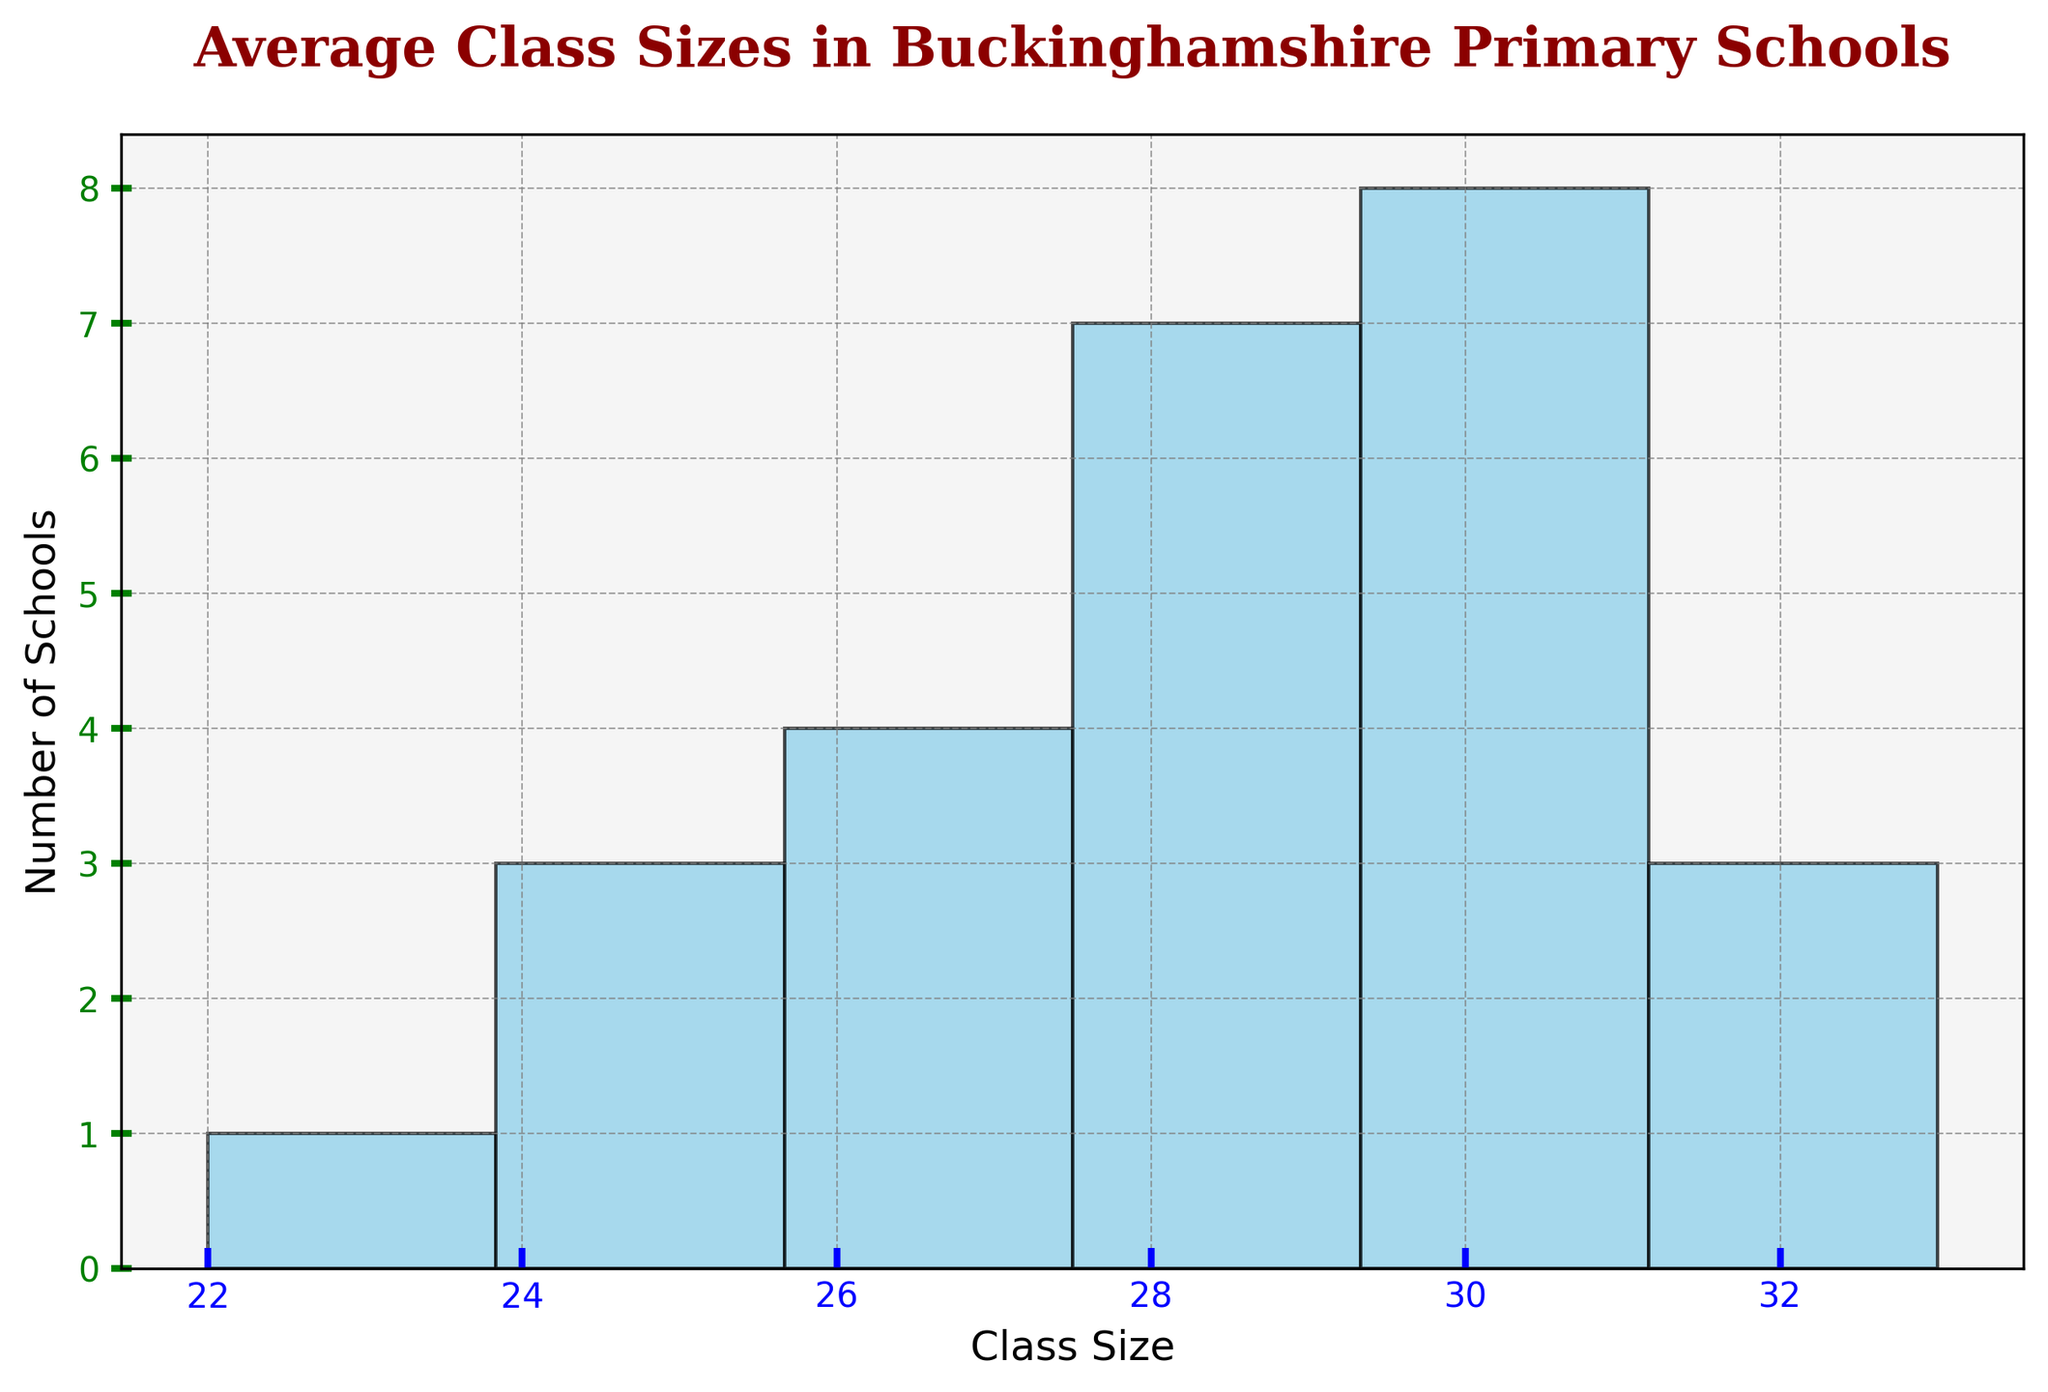How many schools have an average class size of 30? Look for the bars in the histogram that represent the count of schools with an average class size of 30. Note the height of this bar.
Answer: 5 Which class size range contains the most schools? Identify the bar that is the tallest in the histogram. The x-axis label of this bar corresponds to the class size range with the most schools.
Answer: 28-29 How many schools have an average class size below 27? Sum the counts in the bars that correspond to class sizes 22-23, 24-25, and 26-27 in the histogram.
Answer: 5 What's the average class size in the entire histogram? Calculate the sum of (class size * number of schools in that size) for each bin, then divide by the total number of schools.
Answer: 28.4 Which range has the second-highest number of schools? Determine the bar with the second-highest height in the histogram and check its corresponding class size range on the x-axis.
Answer: 30-31 Is there any class size that has exactly 2 schools? Check the heights of the bars; each height represents the number of schools. Identify if any bar has a height precisely equal to 2.
Answer: No In which class size range does the least number of schools fall? Identify the bar with the shortest height. The corresponding class size range on the x-axis indicates the range with the fewest schools.
Answer: 22-23 How many schools have an average class size of 31 or more? Sum the counts in the histogram bars that correspond to class sizes 31-32 and 32-33.
Answer: 5 What's the difference in the number of schools between the most and least populous class size ranges? Subtract the height of the shortest bar from the height of the tallest bar in the histogram.
Answer: 5 